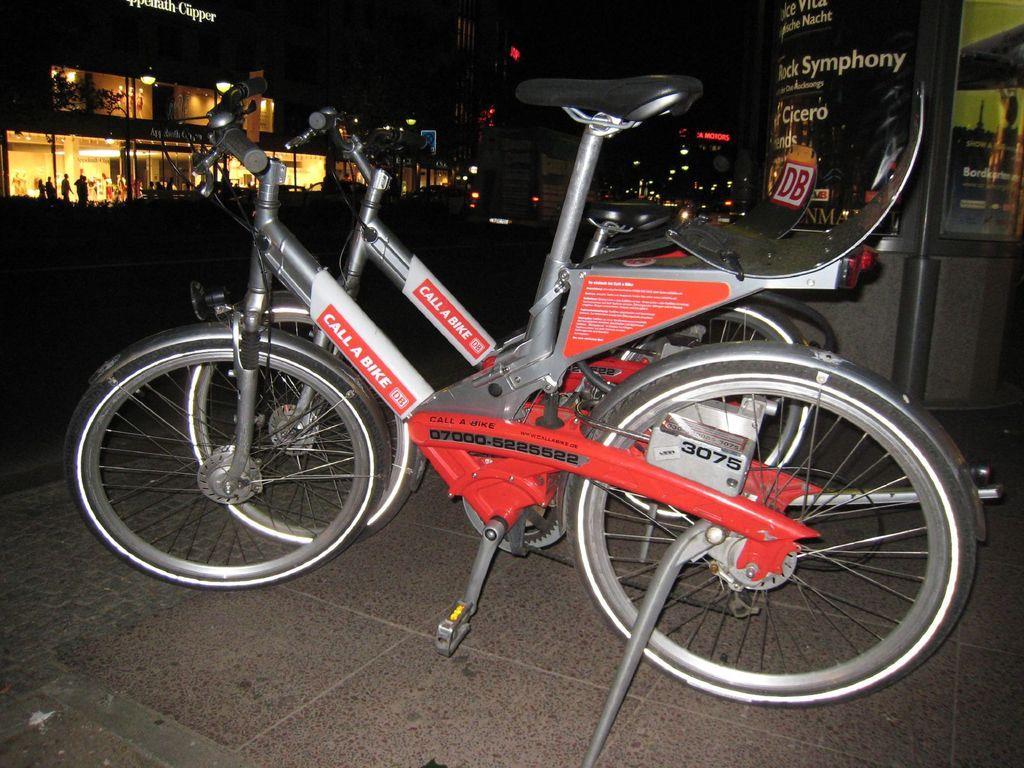Could you give a brief overview of what you see in this image? Here I can see two bicycles on the floor. In the background, I can see few lights, buildings and few people in the dark. 